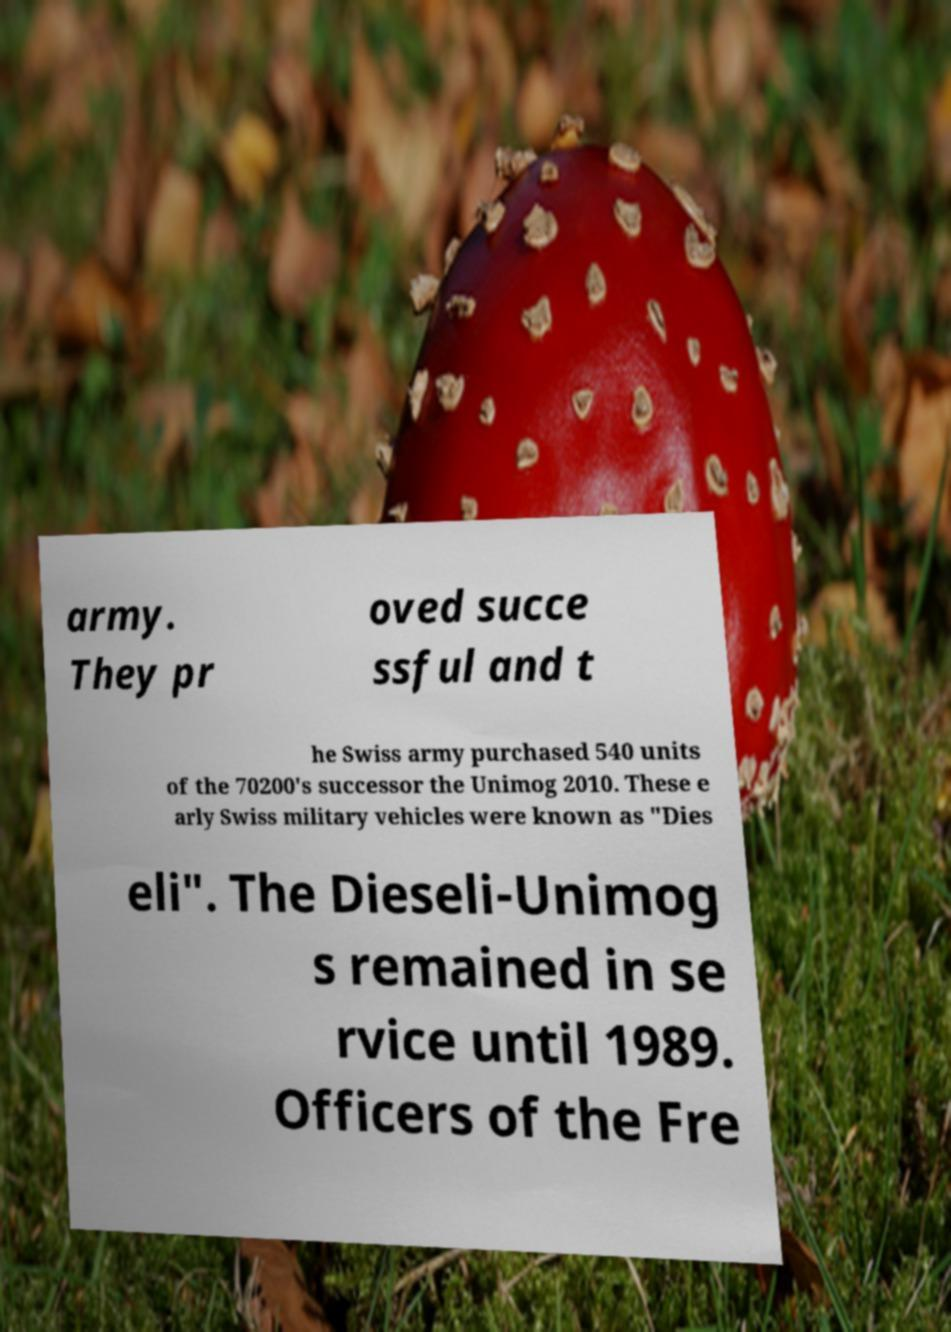There's text embedded in this image that I need extracted. Can you transcribe it verbatim? army. They pr oved succe ssful and t he Swiss army purchased 540 units of the 70200's successor the Unimog 2010. These e arly Swiss military vehicles were known as ″Dies eli″. The Dieseli-Unimog s remained in se rvice until 1989. Officers of the Fre 